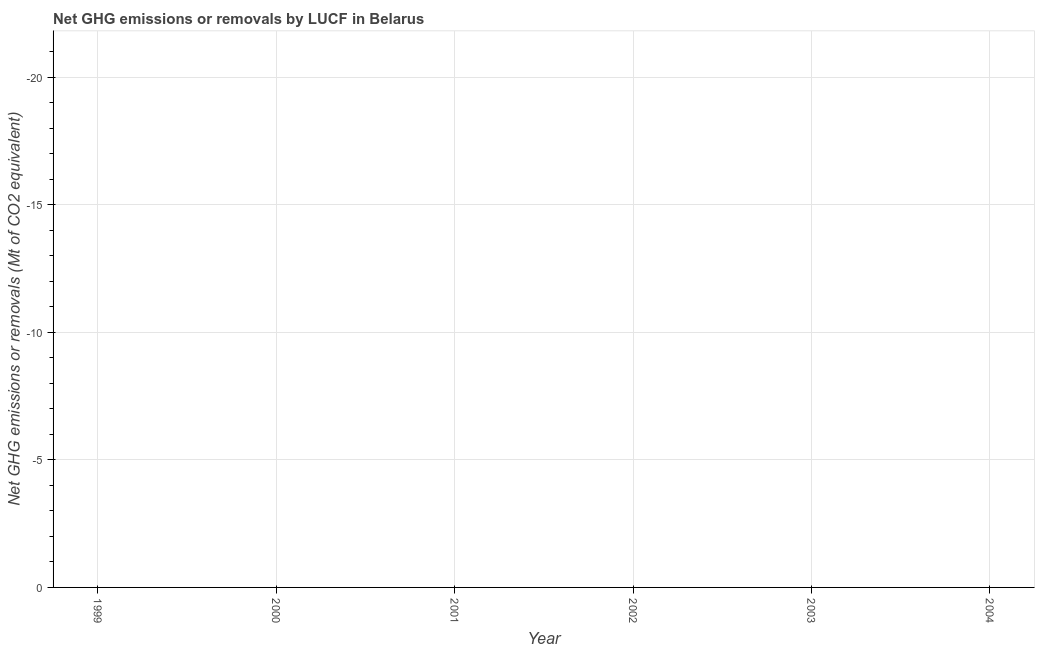What is the ghg net emissions or removals in 2002?
Provide a succinct answer. 0. Across all years, what is the minimum ghg net emissions or removals?
Provide a succinct answer. 0. What is the sum of the ghg net emissions or removals?
Make the answer very short. 0. What is the median ghg net emissions or removals?
Keep it short and to the point. 0. In how many years, is the ghg net emissions or removals greater than -14 Mt?
Ensure brevity in your answer.  0. In how many years, is the ghg net emissions or removals greater than the average ghg net emissions or removals taken over all years?
Your answer should be compact. 0. Does the ghg net emissions or removals monotonically increase over the years?
Provide a short and direct response. No. How many years are there in the graph?
Give a very brief answer. 6. What is the difference between two consecutive major ticks on the Y-axis?
Provide a short and direct response. 5. Does the graph contain any zero values?
Ensure brevity in your answer.  Yes. What is the title of the graph?
Make the answer very short. Net GHG emissions or removals by LUCF in Belarus. What is the label or title of the Y-axis?
Your answer should be very brief. Net GHG emissions or removals (Mt of CO2 equivalent). What is the Net GHG emissions or removals (Mt of CO2 equivalent) in 1999?
Offer a terse response. 0. What is the Net GHG emissions or removals (Mt of CO2 equivalent) in 2001?
Your response must be concise. 0. What is the Net GHG emissions or removals (Mt of CO2 equivalent) of 2002?
Your answer should be very brief. 0. What is the Net GHG emissions or removals (Mt of CO2 equivalent) of 2003?
Provide a short and direct response. 0. 